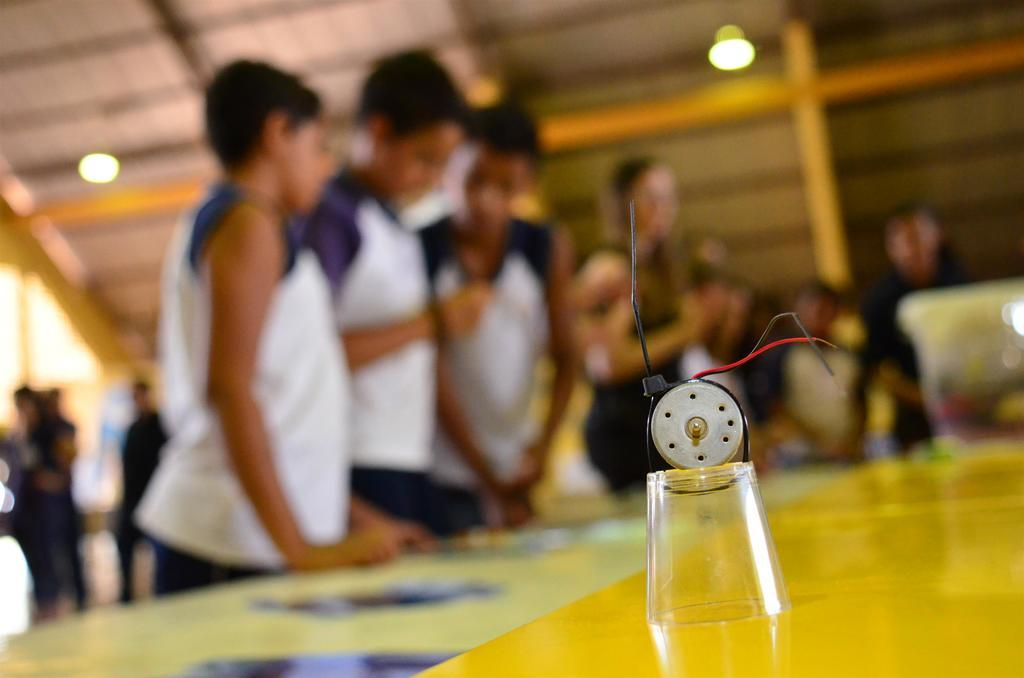What is the main piece of furniture in the image? There is a table in the image. What is placed on the table? There is a glass with wires on the table, along with other items. Can you describe the background of the image? The background of the image is blurred, but there are many people visible. What type of lighting is present in the image? There are lights on the ceiling in the image. How does the fog affect the dinner in the image? There is no fog present in the image, and no dinner is mentioned. 